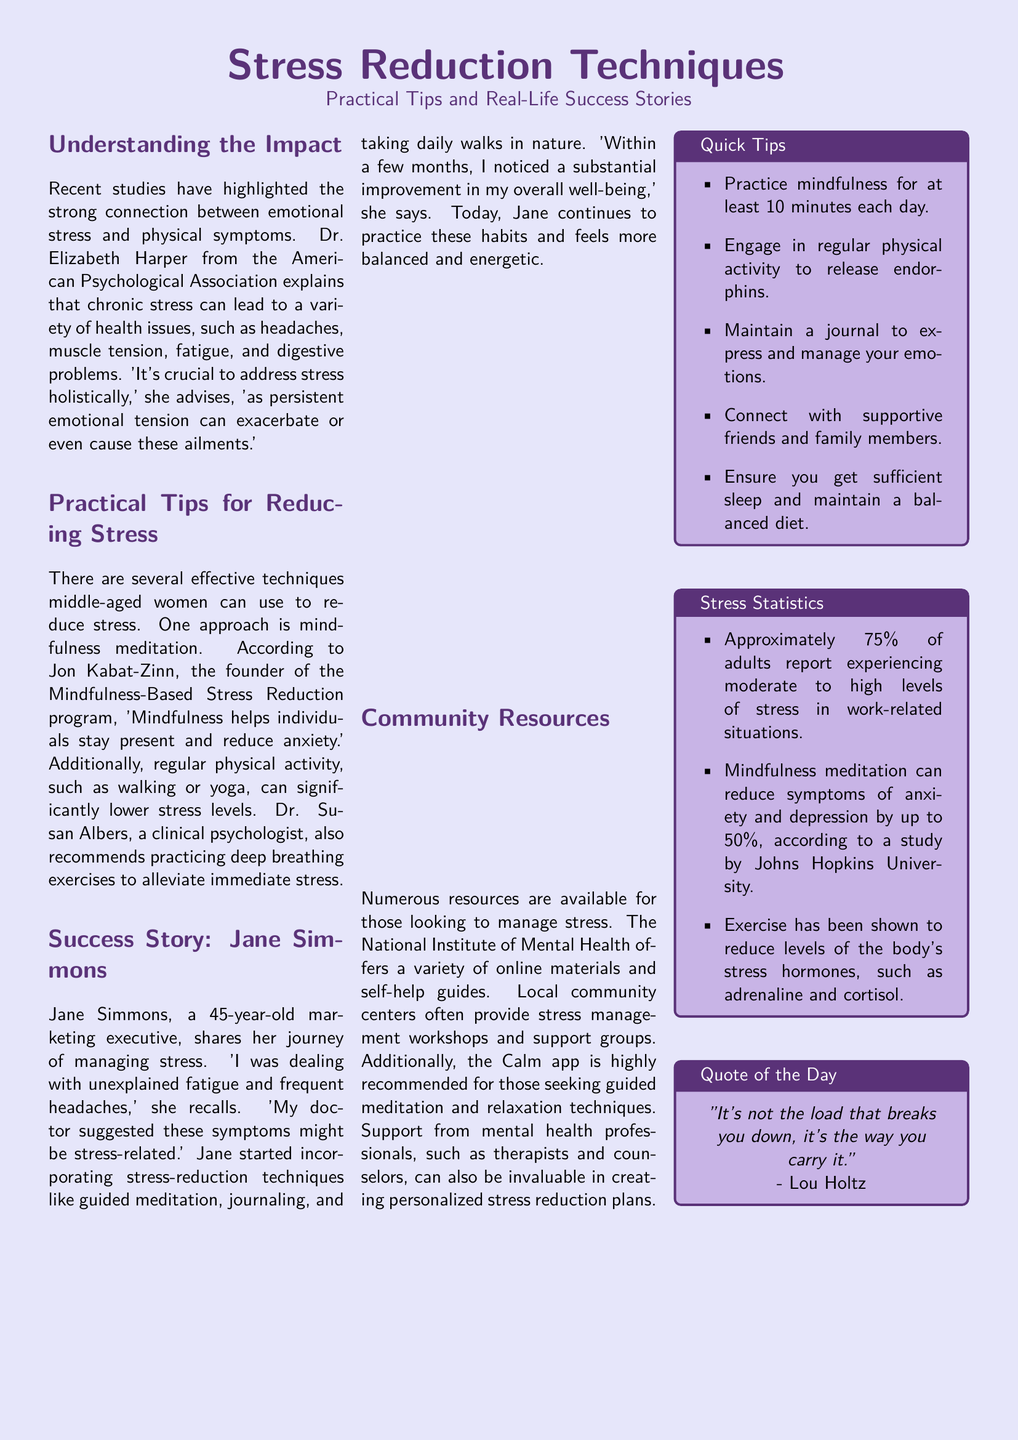What is the profession of Jane Simmons? Jane Simmons is a marketing executive as mentioned in her success story.
Answer: marketing executive Who is the author of the quote in the document? The quote is attributed to Lou Holtz, as stated in the quote box.
Answer: Lou Holtz What technique is recommended for reducing anxiety? Mindfulness meditation is specifically mentioned as a technique for reducing anxiety.
Answer: mindfulness meditation How long should one practice mindfulness daily? The quick tips section states that one should practice mindfulness for at least 10 minutes each day.
Answer: 10 minutes What percentage of adults experience moderate to high stress in work-related situations? The document mentions that approximately 75% of adults report experiencing this level of stress.
Answer: 75% What exercise is suggested by Dr. Susan Albers? Dr. Susan Albers recommends practicing deep breathing exercises.
Answer: deep breathing exercises Which app is recommended for guided meditation? The Calm app is mentioned as a resource for guided meditation and relaxation techniques.
Answer: Calm app What must be maintained alongside sufficient sleep according to the quick tips? A balanced diet is highlighted as important to maintain alongside sufficient sleep.
Answer: balanced diet What is the main topic of the document? The main topic revolves around stress reduction techniques, as stated in the title.
Answer: stress reduction techniques 